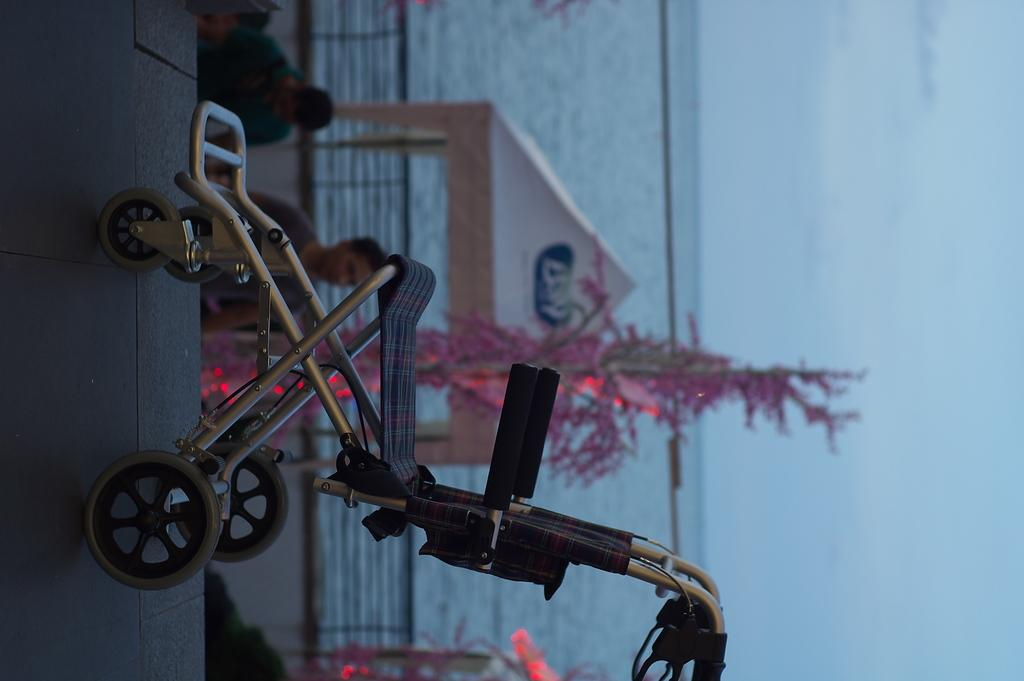What type of mobility aid is present in the image? There is a wheelchair in the image. What natural element is visible in the image? There is water in the image. What type of vegetation is present in the image? There is a plant in the image. What part of the sky is visible in the image? The sky is visible on the right side of the image. How many chickens are visible in the image? There are no chickens present in the image. What type of ghost is haunting the wheelchair in the image? There is no ghost present in the image. 